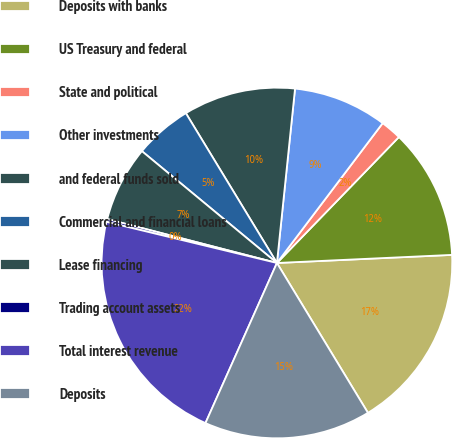Convert chart to OTSL. <chart><loc_0><loc_0><loc_500><loc_500><pie_chart><fcel>Deposits with banks<fcel>US Treasury and federal<fcel>State and political<fcel>Other investments<fcel>and federal funds sold<fcel>Commercial and financial loans<fcel>Lease financing<fcel>Trading account assets<fcel>Total interest revenue<fcel>Deposits<nl><fcel>17.05%<fcel>12.02%<fcel>1.94%<fcel>8.66%<fcel>10.34%<fcel>5.3%<fcel>6.98%<fcel>0.26%<fcel>22.09%<fcel>15.37%<nl></chart> 